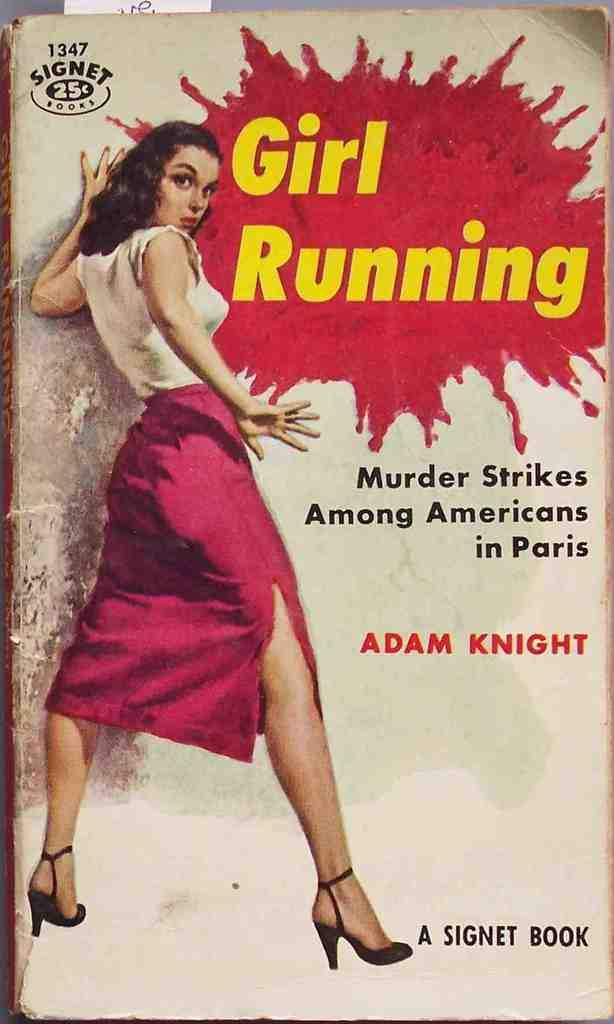<image>
Create a compact narrative representing the image presented. A book titled Girl Running with an image of a woman on the cover. 